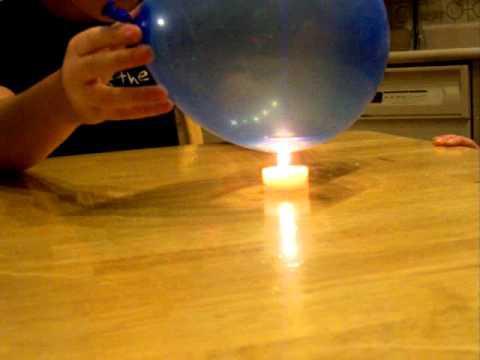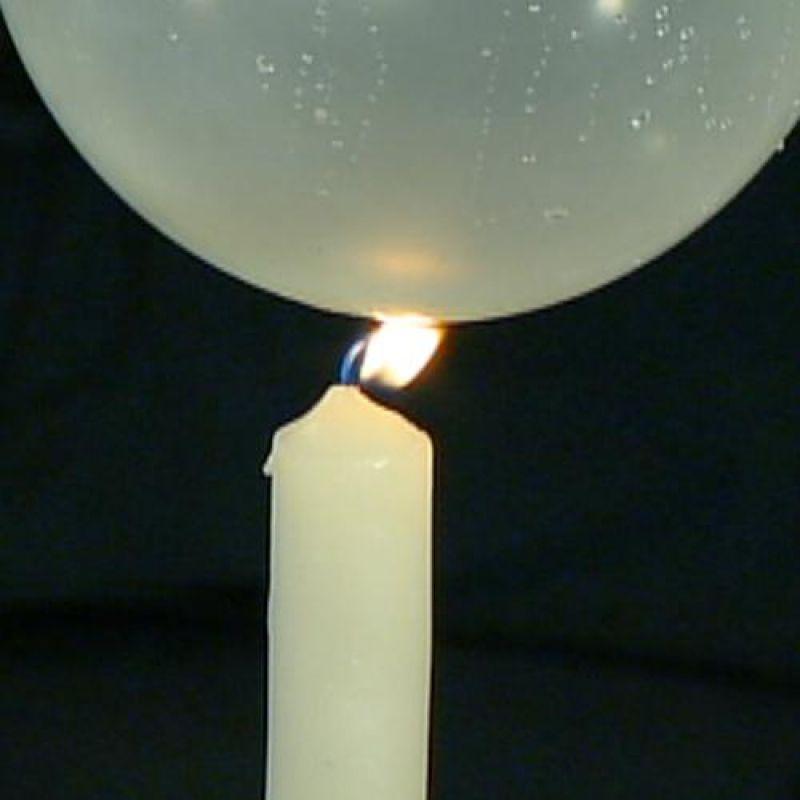The first image is the image on the left, the second image is the image on the right. Evaluate the accuracy of this statement regarding the images: "In at least one image there is a single balloon being filled from a water faucet.". Is it true? Answer yes or no. No. The first image is the image on the left, the second image is the image on the right. Analyze the images presented: Is the assertion "A partially filled balloon is attached to a faucet." valid? Answer yes or no. No. 